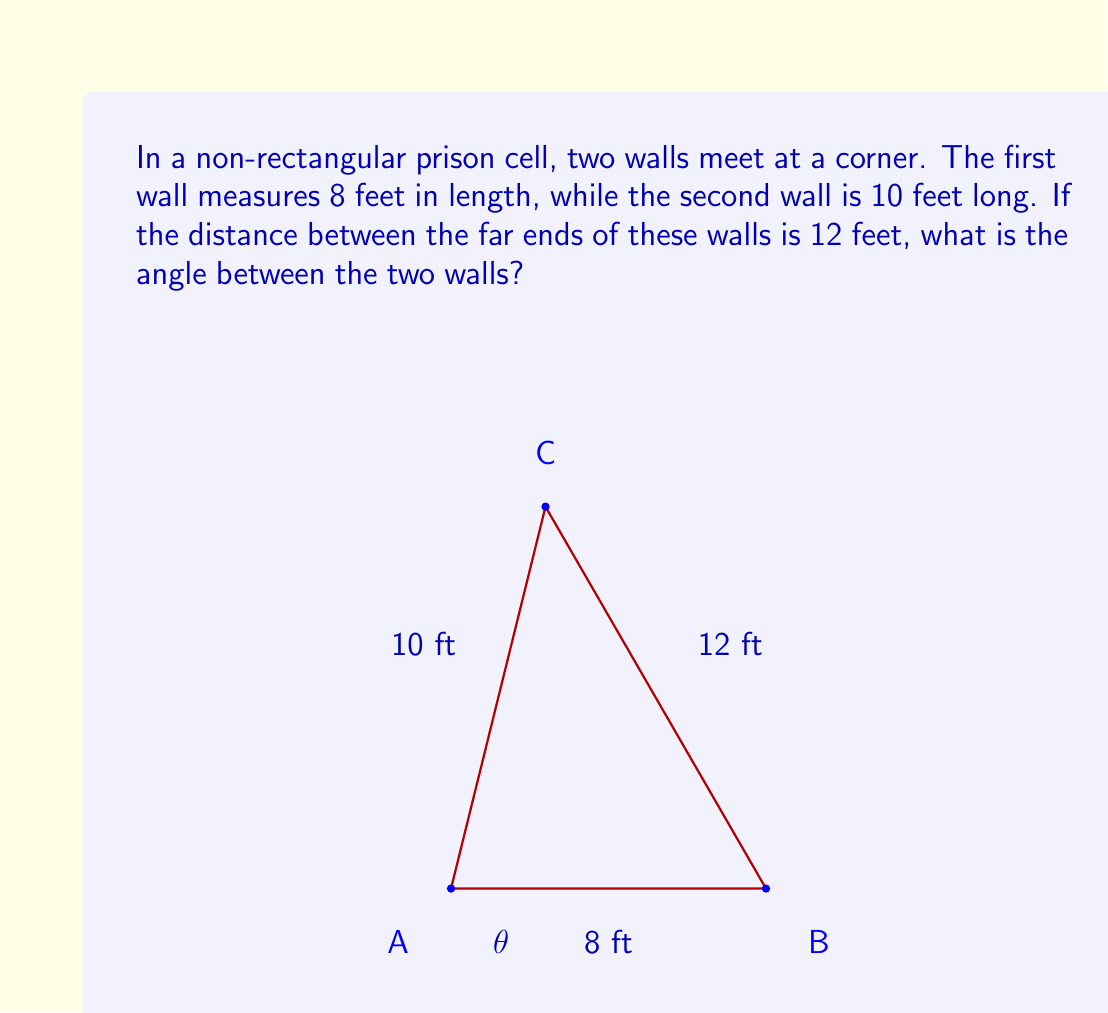Give your solution to this math problem. To solve this problem, we can use the law of cosines. Let's approach this step-by-step:

1) Let's denote the angle we're looking for as $\theta$.

2) The law of cosines states that in a triangle with sides a, b, and c, and an angle $\theta$ opposite the side c:

   $$c^2 = a^2 + b^2 - 2ab \cos(\theta)$$

3) In our case:
   a = 8 feet (first wall)
   b = 10 feet (second wall)
   c = 12 feet (distance between far ends)

4) Plugging these into the law of cosines:

   $$12^2 = 8^2 + 10^2 - 2(8)(10)\cos(\theta)$$

5) Simplify:

   $$144 = 64 + 100 - 160\cos(\theta)$$

6) Combine like terms:

   $$144 = 164 - 160\cos(\theta)$$

7) Subtract 164 from both sides:

   $$-20 = -160\cos(\theta)$$

8) Divide both sides by -160:

   $$\frac{1}{8} = \cos(\theta)$$

9) To find $\theta$, we need to take the inverse cosine (arccos) of both sides:

   $$\theta = \arccos(\frac{1}{8})$$

10) Using a calculator or computer, we can evaluate this:

    $$\theta \approx 82.82^\circ$$
Answer: The angle between the two prison walls is approximately $82.82^\circ$. 